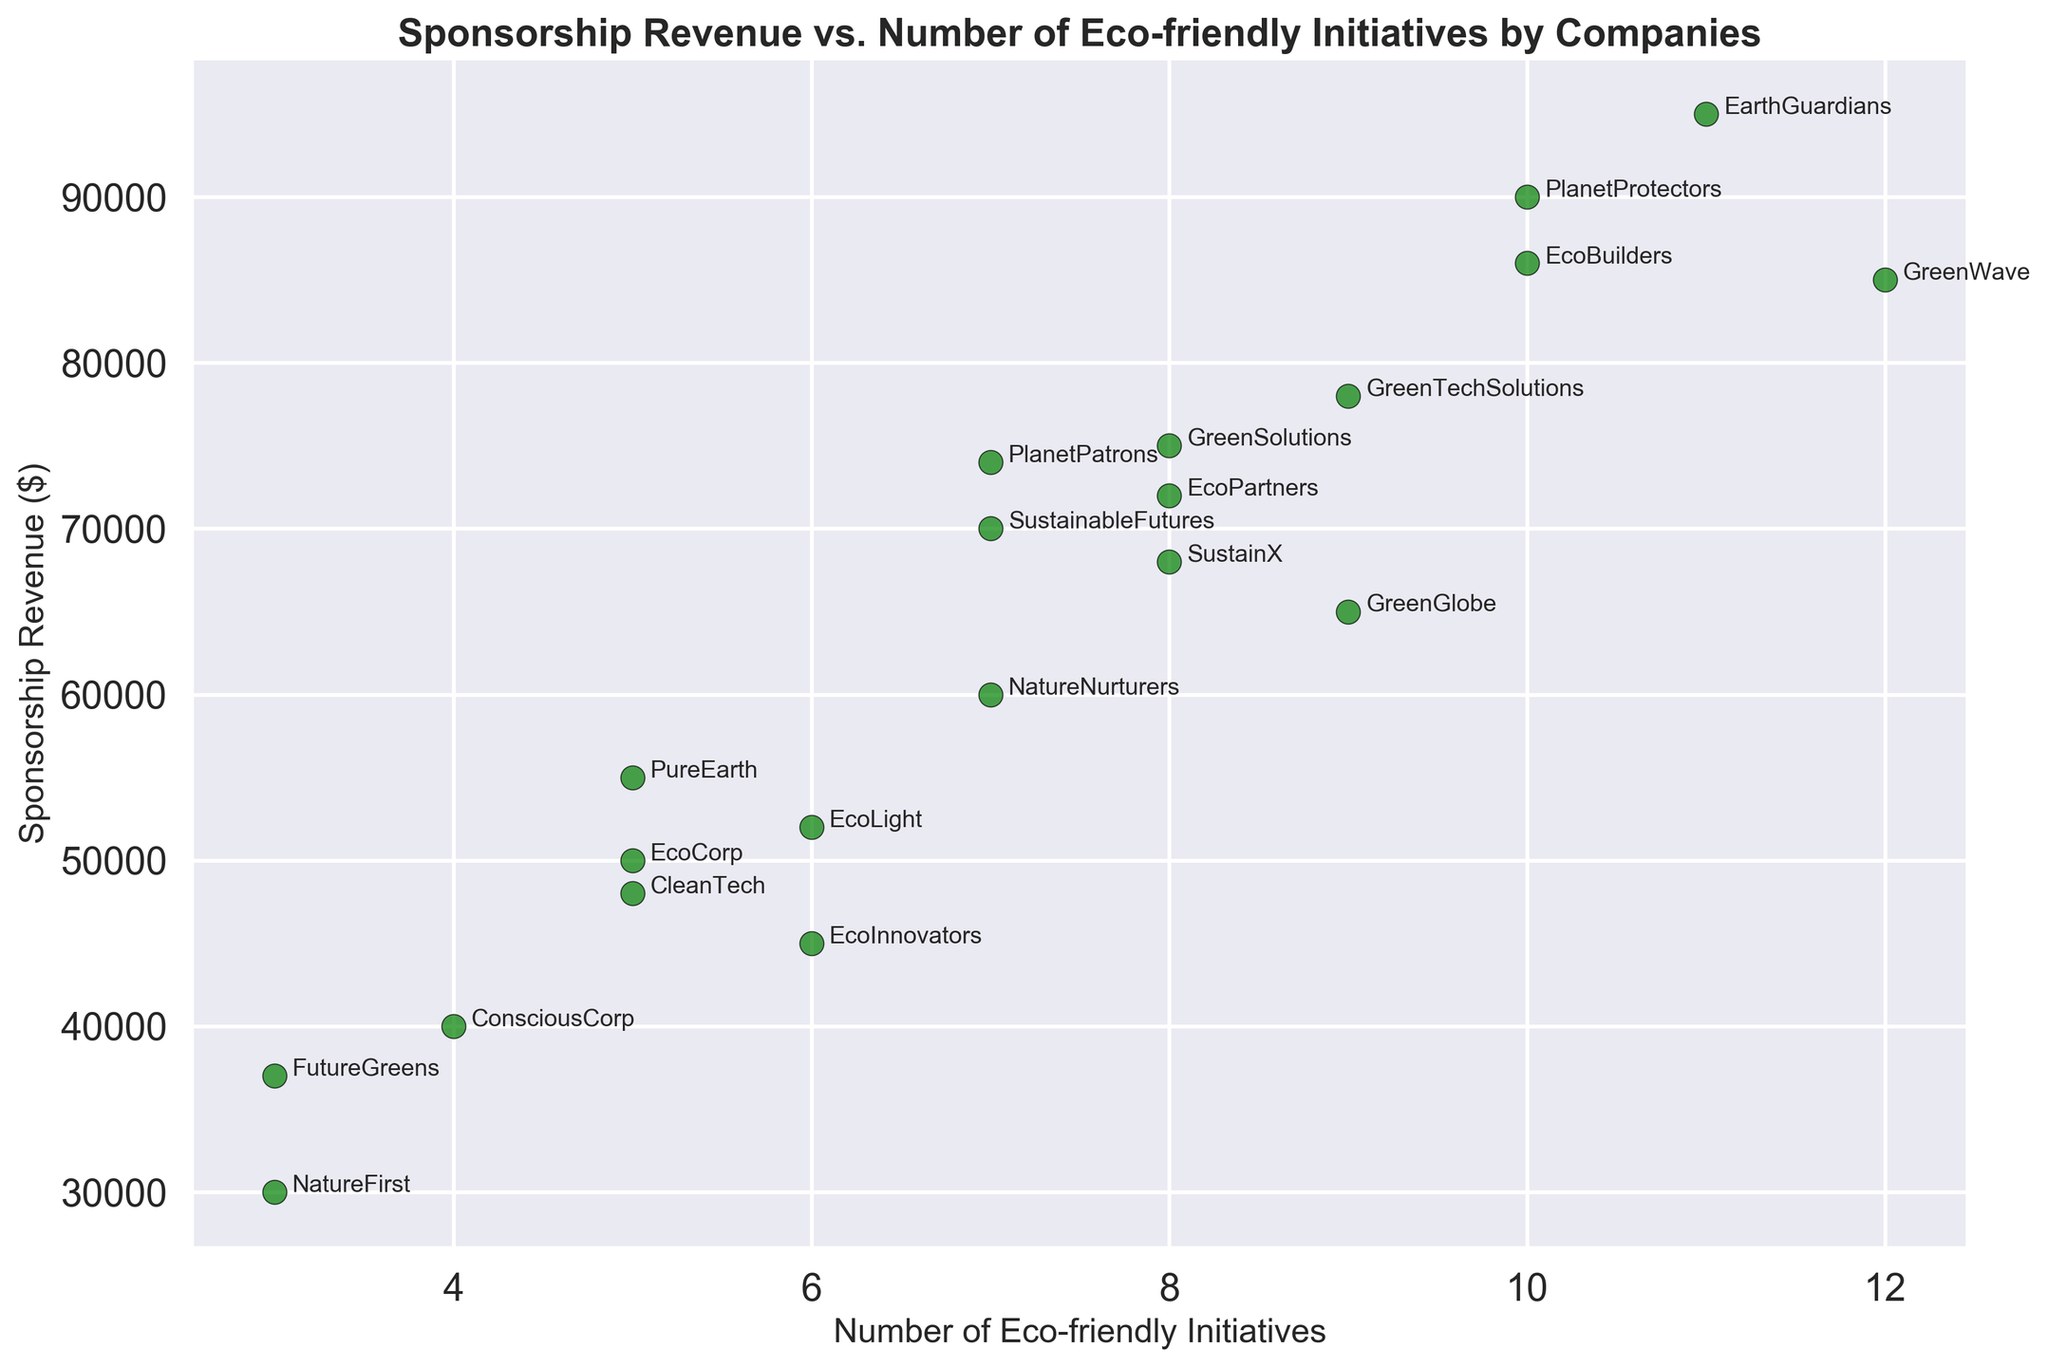What's the relationship trend between the number of eco-friendly initiatives and sponsorship revenue? The scatter plot shows a positive trend, indicating that companies with more eco-friendly initiatives tend to have higher sponsorship revenues. Key points are companies like EcoBuilders and EarthGuardians with high initiatives and revenues.
Answer: Positive trend Which company has the highest sponsorship revenue, and how many eco-friendly initiatives do they have? The company with the highest sponsorship revenue is EarthGuardians at $95,000. They have 11 eco-friendly initiatives. This information is visible in the upper end of the scatter plot.
Answer: EarthGuardians, 11 Are there any companies with the same number of eco-friendly initiatives but different sponsorship revenues? If so, name one pair. Yes, for example, PureEarth, CleanTech, and EcoCorp all have 5 eco-friendly initiatives but have different sponsorship revenues of $55,000, $48,000, and $50,000 respectively.
Answer: PureEarth and CleanTech What's the average sponsorship revenue for companies with more than 8 eco-friendly initiatives? Companies with more than 8 eco-friendly initiatives are PlanetProtectors, GreenGlobe, EarthGuardians, GreenWave, and EcoBuilders. Their revenues are $90,000, $65,000, $95,000, $85,000, and $86,000. Sum these revenues to get $421,000, and the average is $421,000 / 5 = $84,200.
Answer: $84,200 Which company has the lowest number of eco-friendly initiatives, and what is their sponsorship revenue? The company with the lowest number of eco-friendly initiatives is NatureFirst with 3 initiatives and a sponsorship revenue of $30,000. This is evident at the lower extreme of the scatter plot.
Answer: NatureFirst, $30,000 Is there a company with a sponsorship revenue around $70,000, and how many eco-friendly initiatives do they have? Yes, SustainableFutures has a sponsorship revenue of $70,000 and they have 7 eco-friendly initiatives, which can be found by looking at the data around the $70,000 mark on the scatter plot.
Answer: SustainableFutures, 7 How many companies have eco-friendly initiatives between 5 and 7? What are their average sponsorship revenues? Companies with eco-friendly initiatives between 5 and 7 are EcoCorp, PureEarth, CleanTech, EcoLight, NatureNurturers, and PlanetPatrons. Their revenues are $50,000, $55,000, $48,000, $52,000, $60,000, and $74,000 respectively. Sum these to get $339,000, and the average is $339,000 / 6 = $56,500.
Answer: $56,500 Which company with 10 or more initiatives has the lowest sponsorship revenue? Among companies with 10 or more initiatives, GreenWave has the lowest sponsorship revenue at $85,000. This can be seen by identifying companies with 10 or above initiatives and comparing their revenues.
Answer: GreenWave, $85,000 